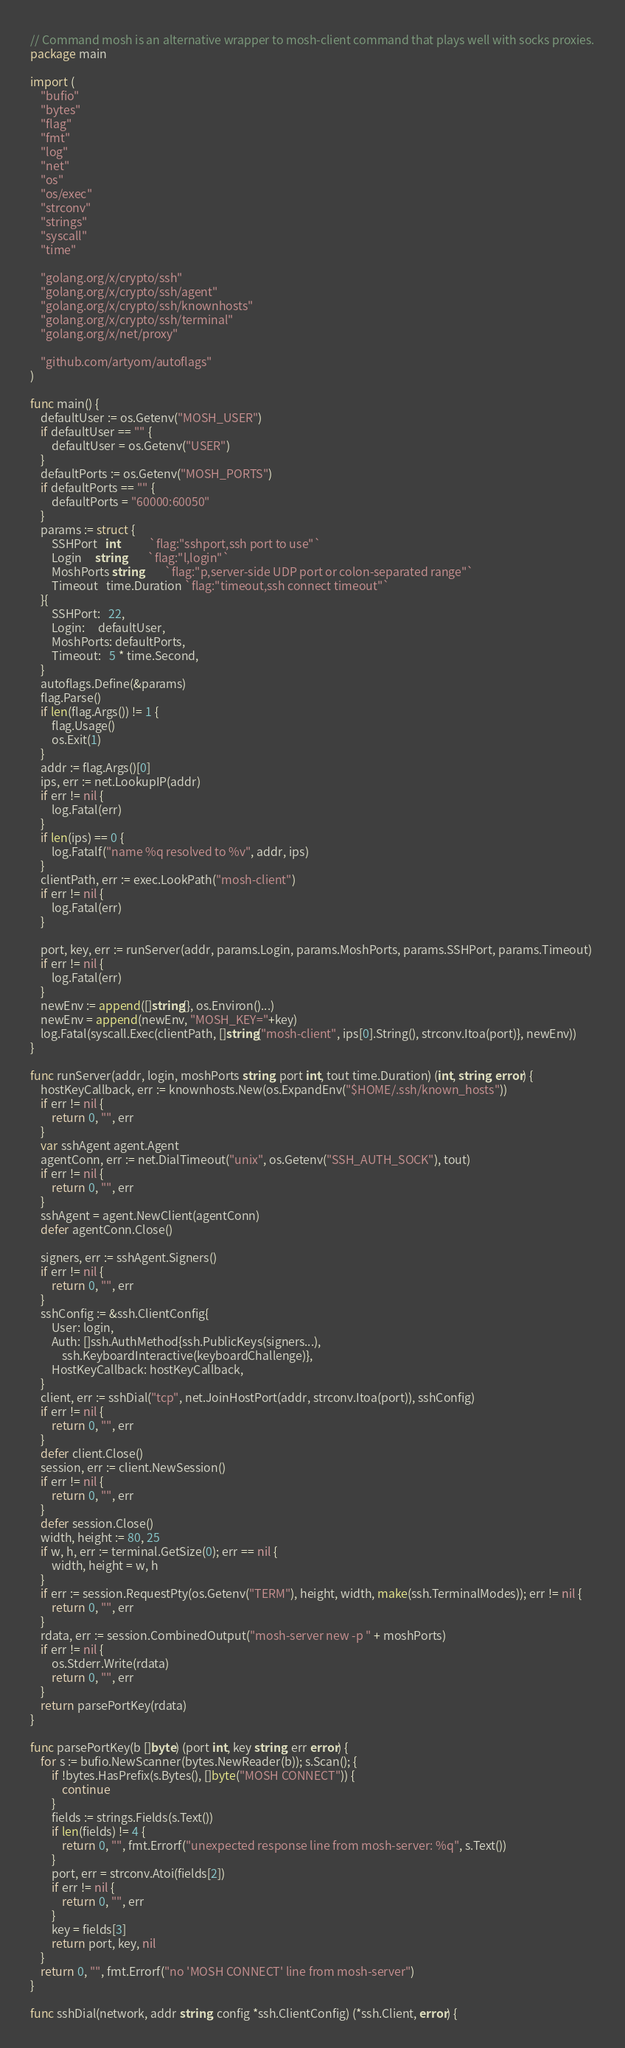Convert code to text. <code><loc_0><loc_0><loc_500><loc_500><_Go_>// Command mosh is an alternative wrapper to mosh-client command that plays well with socks proxies.
package main

import (
	"bufio"
	"bytes"
	"flag"
	"fmt"
	"log"
	"net"
	"os"
	"os/exec"
	"strconv"
	"strings"
	"syscall"
	"time"

	"golang.org/x/crypto/ssh"
	"golang.org/x/crypto/ssh/agent"
	"golang.org/x/crypto/ssh/knownhosts"
	"golang.org/x/crypto/ssh/terminal"
	"golang.org/x/net/proxy"

	"github.com/artyom/autoflags"
)

func main() {
	defaultUser := os.Getenv("MOSH_USER")
	if defaultUser == "" {
		defaultUser = os.Getenv("USER")
	}
	defaultPorts := os.Getenv("MOSH_PORTS")
	if defaultPorts == "" {
		defaultPorts = "60000:60050"
	}
	params := struct {
		SSHPort   int           `flag:"sshport,ssh port to use"`
		Login     string        `flag:"l,login"`
		MoshPorts string        `flag:"p,server-side UDP port or colon-separated range"`
		Timeout   time.Duration `flag:"timeout,ssh connect timeout"`
	}{
		SSHPort:   22,
		Login:     defaultUser,
		MoshPorts: defaultPorts,
		Timeout:   5 * time.Second,
	}
	autoflags.Define(&params)
	flag.Parse()
	if len(flag.Args()) != 1 {
		flag.Usage()
		os.Exit(1)
	}
	addr := flag.Args()[0]
	ips, err := net.LookupIP(addr)
	if err != nil {
		log.Fatal(err)
	}
	if len(ips) == 0 {
		log.Fatalf("name %q resolved to %v", addr, ips)
	}
	clientPath, err := exec.LookPath("mosh-client")
	if err != nil {
		log.Fatal(err)
	}

	port, key, err := runServer(addr, params.Login, params.MoshPorts, params.SSHPort, params.Timeout)
	if err != nil {
		log.Fatal(err)
	}
	newEnv := append([]string{}, os.Environ()...)
	newEnv = append(newEnv, "MOSH_KEY="+key)
	log.Fatal(syscall.Exec(clientPath, []string{"mosh-client", ips[0].String(), strconv.Itoa(port)}, newEnv))
}

func runServer(addr, login, moshPorts string, port int, tout time.Duration) (int, string, error) {
	hostKeyCallback, err := knownhosts.New(os.ExpandEnv("$HOME/.ssh/known_hosts"))
	if err != nil {
		return 0, "", err
	}
	var sshAgent agent.Agent
	agentConn, err := net.DialTimeout("unix", os.Getenv("SSH_AUTH_SOCK"), tout)
	if err != nil {
		return 0, "", err
	}
	sshAgent = agent.NewClient(agentConn)
	defer agentConn.Close()

	signers, err := sshAgent.Signers()
	if err != nil {
		return 0, "", err
	}
	sshConfig := &ssh.ClientConfig{
		User: login,
		Auth: []ssh.AuthMethod{ssh.PublicKeys(signers...),
			ssh.KeyboardInteractive(keyboardChallenge)},
		HostKeyCallback: hostKeyCallback,
	}
	client, err := sshDial("tcp", net.JoinHostPort(addr, strconv.Itoa(port)), sshConfig)
	if err != nil {
		return 0, "", err
	}
	defer client.Close()
	session, err := client.NewSession()
	if err != nil {
		return 0, "", err
	}
	defer session.Close()
	width, height := 80, 25
	if w, h, err := terminal.GetSize(0); err == nil {
		width, height = w, h
	}
	if err := session.RequestPty(os.Getenv("TERM"), height, width, make(ssh.TerminalModes)); err != nil {
		return 0, "", err
	}
	rdata, err := session.CombinedOutput("mosh-server new -p " + moshPorts)
	if err != nil {
		os.Stderr.Write(rdata)
		return 0, "", err
	}
	return parsePortKey(rdata)
}

func parsePortKey(b []byte) (port int, key string, err error) {
	for s := bufio.NewScanner(bytes.NewReader(b)); s.Scan(); {
		if !bytes.HasPrefix(s.Bytes(), []byte("MOSH CONNECT")) {
			continue
		}
		fields := strings.Fields(s.Text())
		if len(fields) != 4 {
			return 0, "", fmt.Errorf("unexpected response line from mosh-server: %q", s.Text())
		}
		port, err = strconv.Atoi(fields[2])
		if err != nil {
			return 0, "", err
		}
		key = fields[3]
		return port, key, nil
	}
	return 0, "", fmt.Errorf("no 'MOSH CONNECT' line from mosh-server")
}

func sshDial(network, addr string, config *ssh.ClientConfig) (*ssh.Client, error) {</code> 